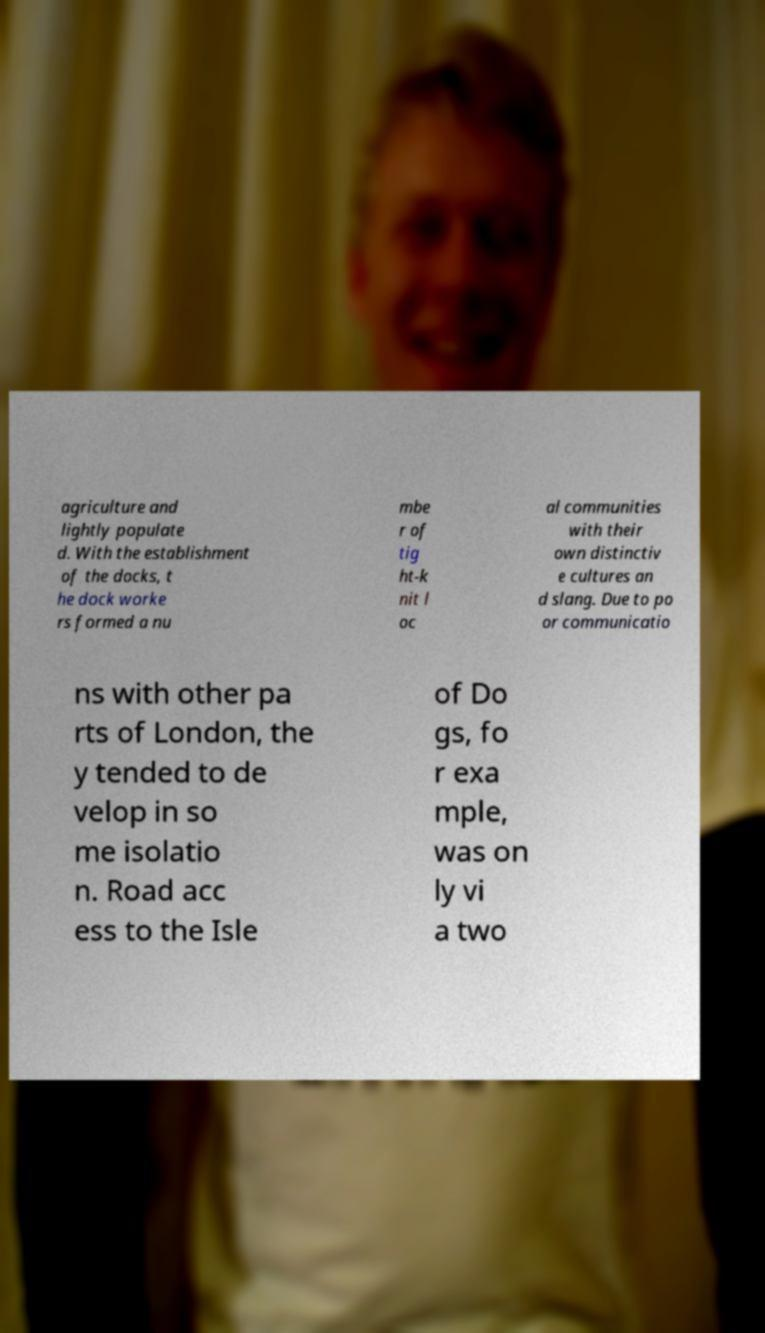There's text embedded in this image that I need extracted. Can you transcribe it verbatim? agriculture and lightly populate d. With the establishment of the docks, t he dock worke rs formed a nu mbe r of tig ht-k nit l oc al communities with their own distinctiv e cultures an d slang. Due to po or communicatio ns with other pa rts of London, the y tended to de velop in so me isolatio n. Road acc ess to the Isle of Do gs, fo r exa mple, was on ly vi a two 